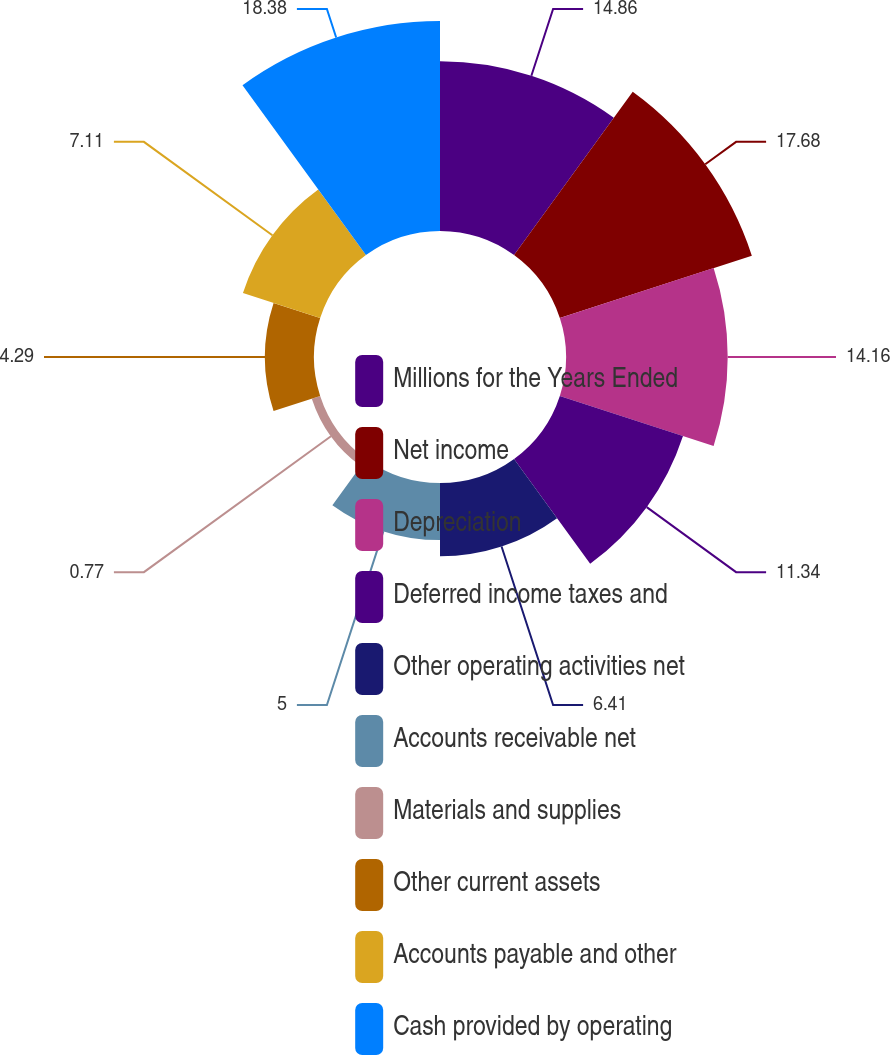Convert chart. <chart><loc_0><loc_0><loc_500><loc_500><pie_chart><fcel>Millions for the Years Ended<fcel>Net income<fcel>Depreciation<fcel>Deferred income taxes and<fcel>Other operating activities net<fcel>Accounts receivable net<fcel>Materials and supplies<fcel>Other current assets<fcel>Accounts payable and other<fcel>Cash provided by operating<nl><fcel>14.86%<fcel>17.68%<fcel>14.16%<fcel>11.34%<fcel>6.41%<fcel>5.0%<fcel>0.77%<fcel>4.29%<fcel>7.11%<fcel>18.39%<nl></chart> 